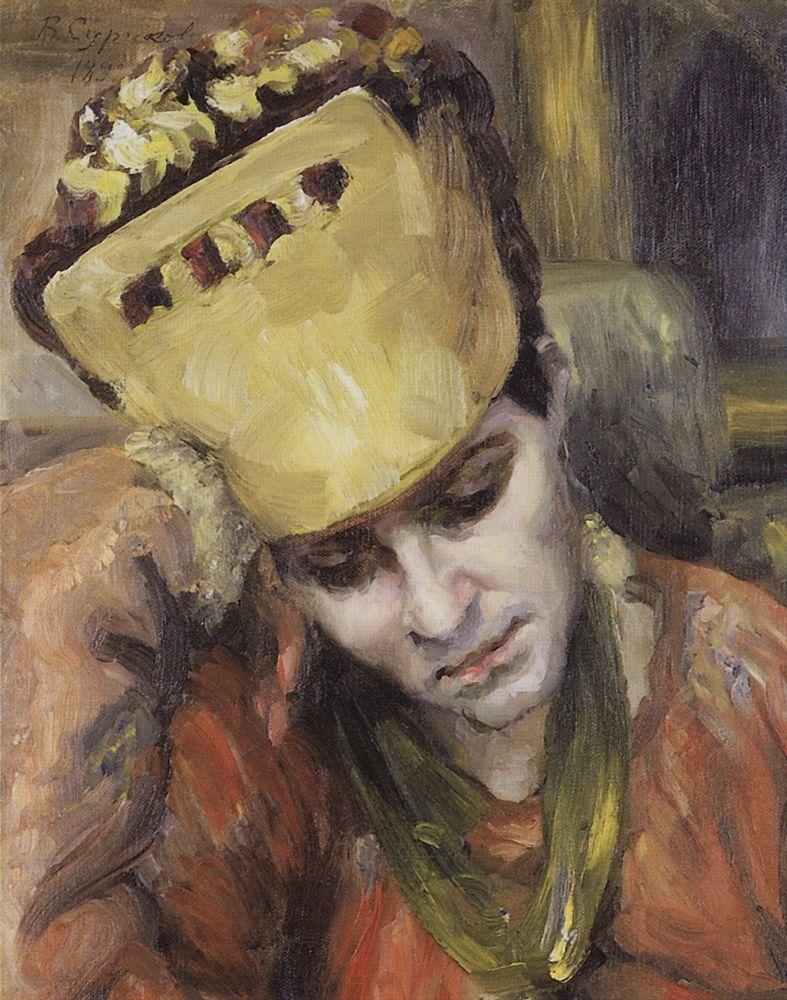Describe the mood of this painting. The mood of this painting is contemplative and slightly melancholic. The young woman's downcast eyes and the gentle, pensive tilt of her head suggest that she is deeply absorbed in her thoughts. The warm colors and soft brush strokes create a serene, almost dreamlike atmosphere, fostering a sense of quiet introspection and emotional depth. 